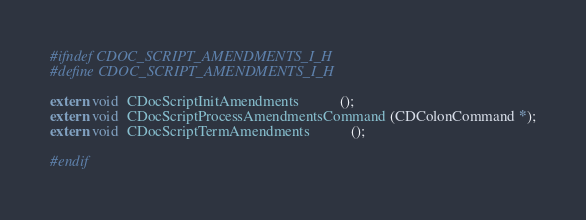<code> <loc_0><loc_0><loc_500><loc_500><_C_>#ifndef CDOC_SCRIPT_AMENDMENTS_I_H
#define CDOC_SCRIPT_AMENDMENTS_I_H

extern void  CDocScriptInitAmendments           ();
extern void  CDocScriptProcessAmendmentsCommand (CDColonCommand *);
extern void  CDocScriptTermAmendments           ();

#endif
</code> 